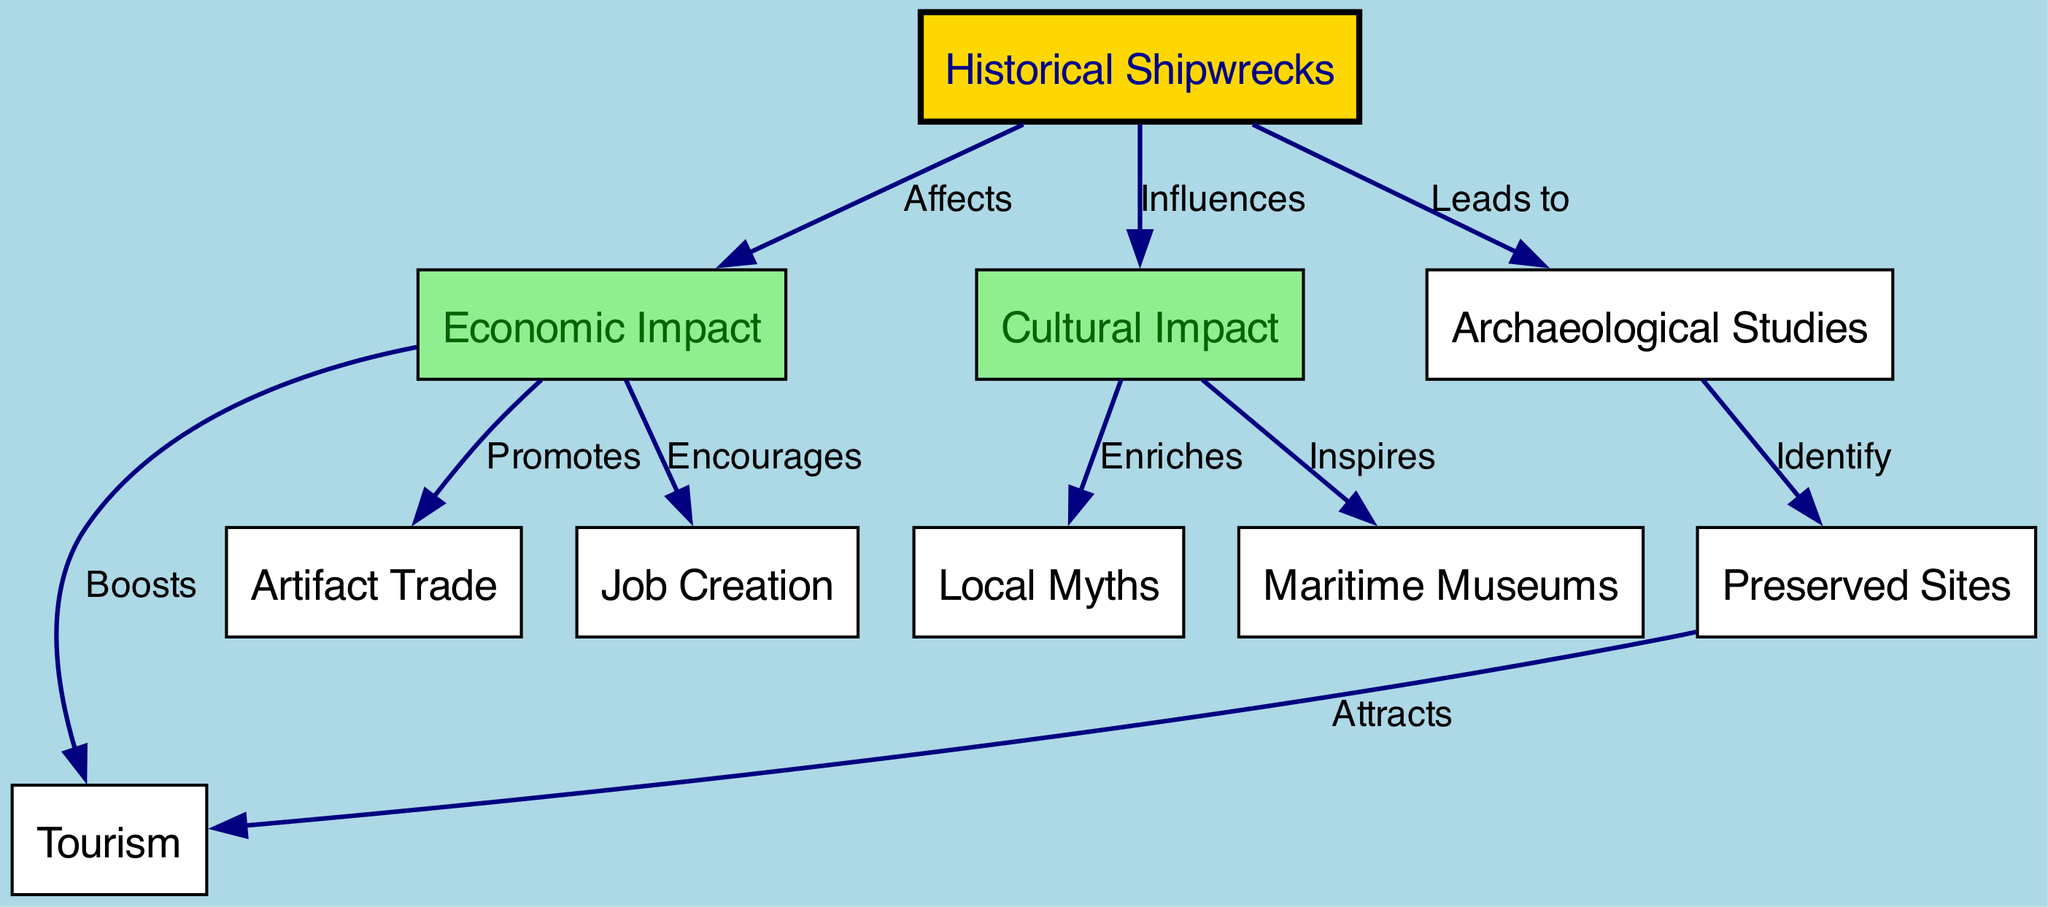What are the two main impacts of historical shipwrecks shown in the diagram? The diagram explicitly connects historical shipwrecks to two main impacts: economic impact and cultural impact, as evidenced by the edges leading from the "shipwreck" node to both of these nodes.
Answer: Economic Impact, Cultural Impact How many nodes are represented in the diagram? By counting all unique entities (nodes) in the diagram, we see there are ten nodes, which can be verified by reviewing the list under the "nodes" section of the data.
Answer: 10 Which node indicates the relationship between economic impact and tourism? The "Boosts" edge specifically connects "economic impact" to "tourism," illustrating that economic benefits linked to shipwrecks enhance tourism opportunities.
Answer: Tourism What does archaeological studies lead to according to the diagram? The diagram shows that "archaeological studies" has an edge leading to "preserved sites," indicating that these studies are responsible for identifying and recognizing preserved historical sites, which are linked to shipwrecks.
Answer: Preserved Sites How does local myths relate to cultural impact? The edge labeled "Enriches" connects "cultural impact" with "local myths," indicating that the cultural implications of shipwrecks help to enhance the myths in the locality, illustrating a relationship of enrichment.
Answer: Local Myths Which impact encourages job creation as shown in the diagram? The edge labeled "Encourages" connects "economic impact" to "job creation," indicating that the economic effects of shipwrecks contribute positively to the creation of jobs in the area.
Answer: Job Creation What type of museum is inspired by cultural impact? The "Inspires" edge connects the "cultural impact" node to "maritime museum," indicating that the cultural significance of shipwrecks contributes to the establishment or enhancement of maritime museums.
Answer: Maritime Museums What is promoted by the economic impact of shipwrecks? Within the diagram, the edge labeled "Promotes" demonstrates that "economic impact" directly supports "artifact trade," indicating that shipwrecks lead to increased trading of artifacts.
Answer: Artifact Trade How do preserved sites attract tourism according to the diagram? The relationship labeled "Attracts" shows a direct line from "preserved sites" to "tourism," illustrating how the presence of preserved sites, likely from shipwrecks, contributes to attracting tourists to the area.
Answer: Tourism 